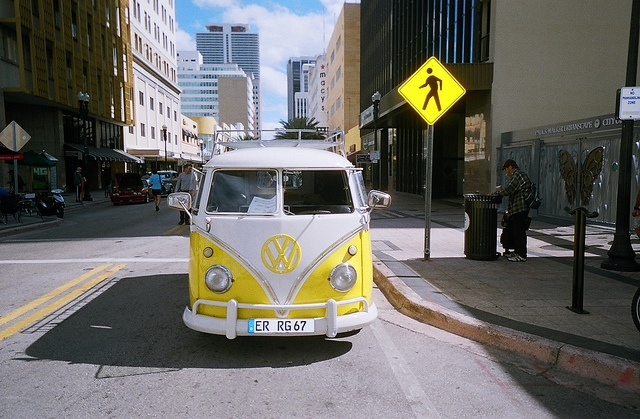Describe the objects in this image and their specific colors. I can see truck in black, lavender, darkgray, and olive tones, people in black, gray, and maroon tones, car in black, gray, and darkblue tones, people in black, gray, darkgray, and lightgray tones, and motorcycle in black, gray, and blue tones in this image. 